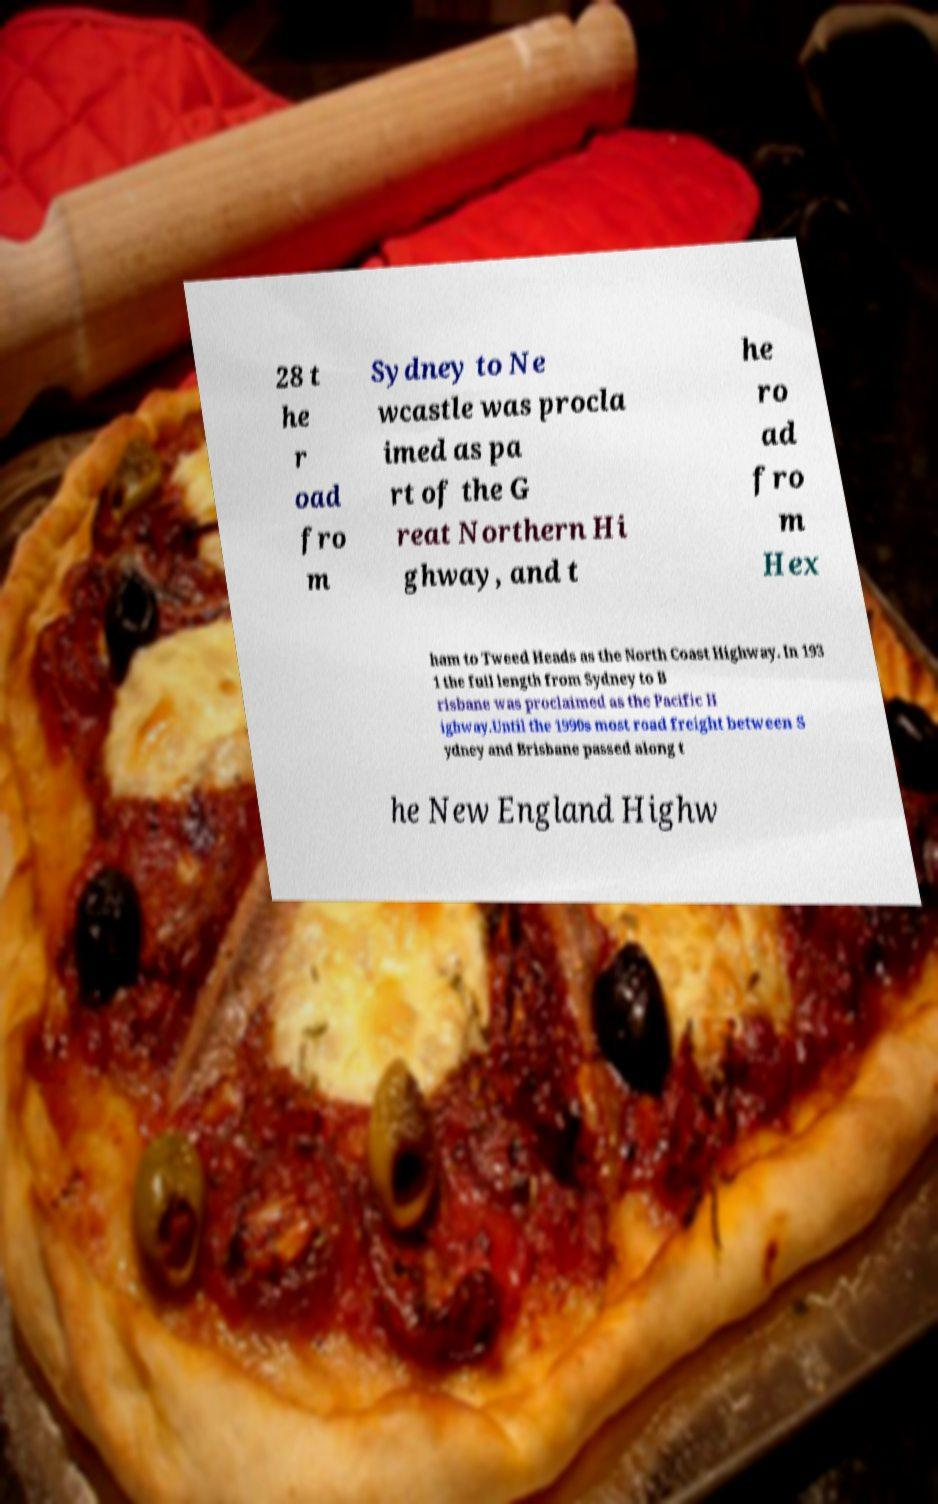Could you extract and type out the text from this image? 28 t he r oad fro m Sydney to Ne wcastle was procla imed as pa rt of the G reat Northern Hi ghway, and t he ro ad fro m Hex ham to Tweed Heads as the North Coast Highway. In 193 1 the full length from Sydney to B risbane was proclaimed as the Pacific H ighway.Until the 1990s most road freight between S ydney and Brisbane passed along t he New England Highw 